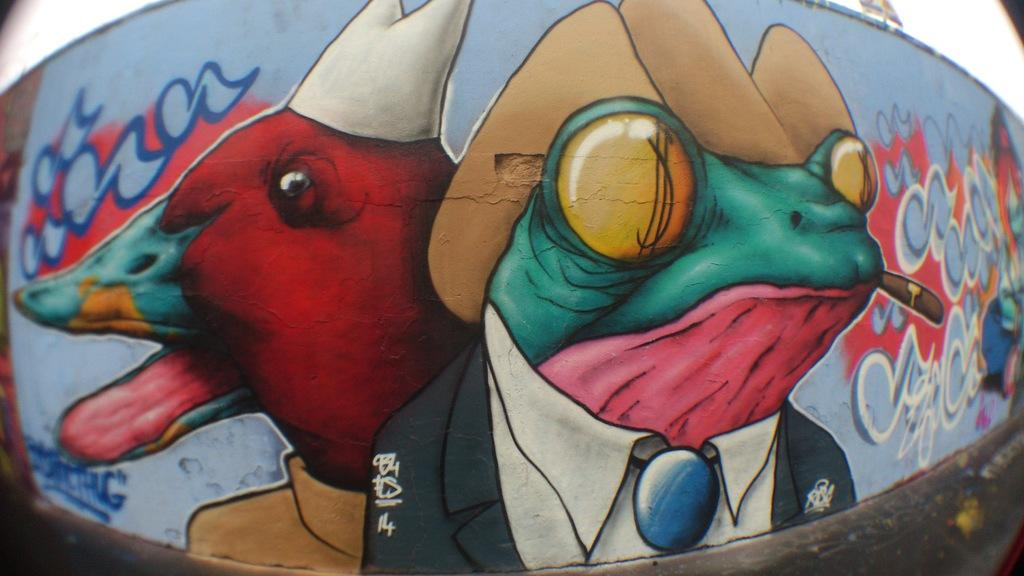What is the condition of the wall in the image? The wall in the image is fully painted. What part of the natural environment can be seen in the image? The sky is visible in the image. How many cherries are hanging from the wall in the image? There are no cherries present in the image. What type of agreement is being made in the image? There is no indication of an agreement being made in the image. 